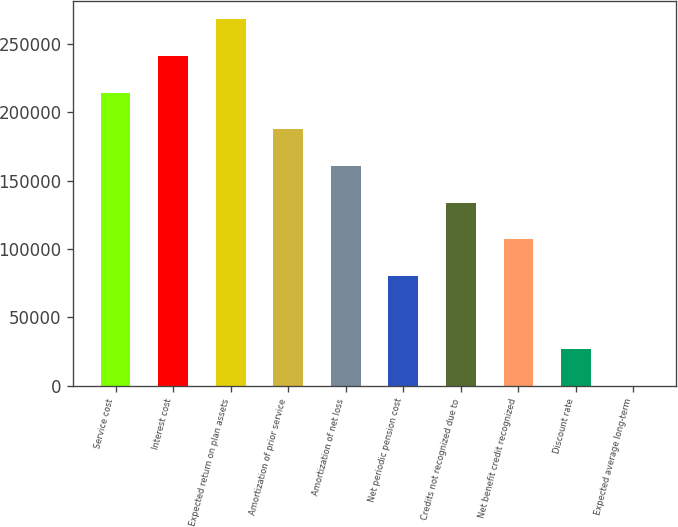Convert chart. <chart><loc_0><loc_0><loc_500><loc_500><bar_chart><fcel>Service cost<fcel>Interest cost<fcel>Expected return on plan assets<fcel>Amortization of prior service<fcel>Amortization of net loss<fcel>Net periodic pension cost<fcel>Credits not recognized due to<fcel>Net benefit credit recognized<fcel>Discount rate<fcel>Expected average long-term<nl><fcel>214453<fcel>241259<fcel>268065<fcel>187647<fcel>160840<fcel>80421.9<fcel>134034<fcel>107228<fcel>26809.7<fcel>3.5<nl></chart> 